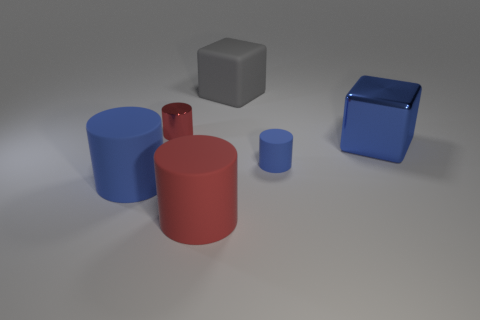What material is the cylinder that is in front of the large matte cylinder to the left of the small red metallic object?
Make the answer very short. Rubber. Are there fewer large blue things that are right of the metal cube than tiny gray metal cubes?
Your response must be concise. No. The tiny object to the right of the large rubber cube has what shape?
Your response must be concise. Cylinder. Do the metal cylinder and the blue object that is left of the red metal thing have the same size?
Offer a terse response. No. Is there a yellow thing that has the same material as the tiny red object?
Offer a very short reply. No. How many spheres are large rubber objects or small metallic things?
Offer a very short reply. 0. There is a big object to the left of the shiny cylinder; is there a block that is in front of it?
Give a very brief answer. No. Is the number of tiny purple metal objects less than the number of big matte cubes?
Offer a very short reply. Yes. What number of large rubber objects are the same shape as the blue metal object?
Provide a succinct answer. 1. How many gray things are blocks or cylinders?
Offer a terse response. 1. 